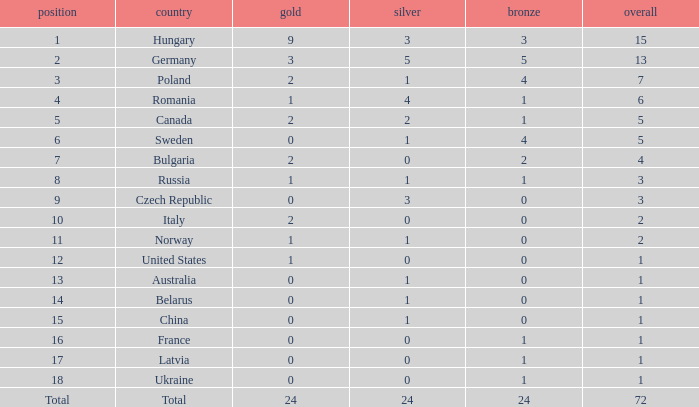How many golds have 3 as the rank, with a total greater than 7? 0.0. 